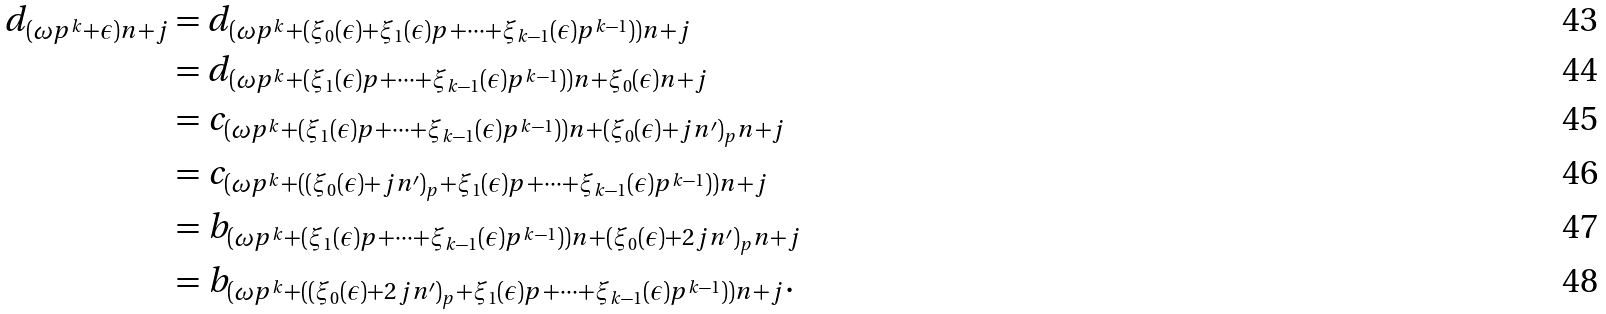<formula> <loc_0><loc_0><loc_500><loc_500>d _ { ( \omega p ^ { k } + \epsilon ) n + j } & = d _ { ( \omega p ^ { k } + ( \xi _ { 0 } ( \epsilon ) + \xi _ { 1 } ( \epsilon ) p + \dots + \xi _ { k - 1 } ( \epsilon ) p ^ { k - 1 } ) ) n + j } \\ & = d _ { ( \omega p ^ { k } + ( \xi _ { 1 } ( \epsilon ) p + \dots + \xi _ { k - 1 } ( \epsilon ) p ^ { k - 1 } ) ) n + \xi _ { 0 } ( \epsilon ) n + j } \\ & = c _ { ( \omega p ^ { k } + ( \xi _ { 1 } ( \epsilon ) p + \dots + \xi _ { k - 1 } ( \epsilon ) p ^ { k - 1 } ) ) n + ( \xi _ { 0 } ( \epsilon ) + j n ^ { \prime } ) _ { p } n + j } \\ & = c _ { ( \omega p ^ { k } + ( ( \xi _ { 0 } ( \epsilon ) + j n ^ { \prime } ) _ { p } + \xi _ { 1 } ( \epsilon ) p + \dots + \xi _ { k - 1 } ( \epsilon ) p ^ { k - 1 } ) ) n + j } \\ & = b _ { ( \omega p ^ { k } + ( \xi _ { 1 } ( \epsilon ) p + \dots + \xi _ { k - 1 } ( \epsilon ) p ^ { k - 1 } ) ) n + ( \xi _ { 0 } ( \epsilon ) + 2 j n ^ { \prime } ) _ { p } n + j } \\ & = b _ { ( \omega p ^ { k } + ( ( \xi _ { 0 } ( \epsilon ) + 2 j n ^ { \prime } ) _ { p } + \xi _ { 1 } ( \epsilon ) p + \dots + \xi _ { k - 1 } ( \epsilon ) p ^ { k - 1 } ) ) n + j } .</formula> 